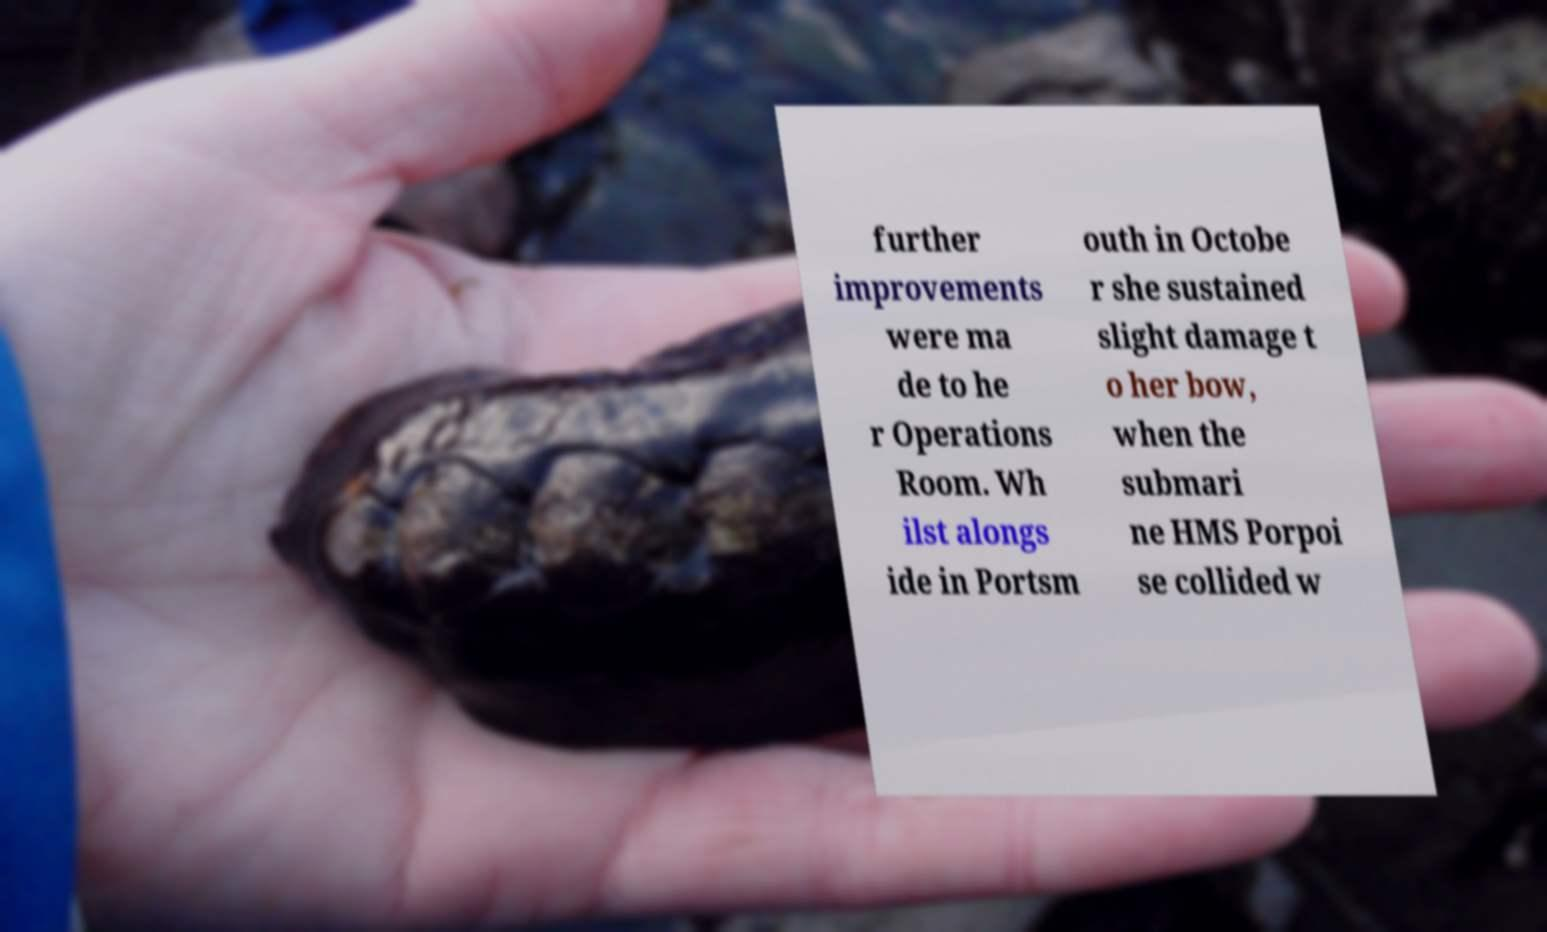Can you accurately transcribe the text from the provided image for me? further improvements were ma de to he r Operations Room. Wh ilst alongs ide in Portsm outh in Octobe r she sustained slight damage t o her bow, when the submari ne HMS Porpoi se collided w 